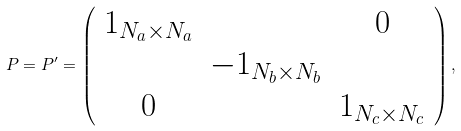<formula> <loc_0><loc_0><loc_500><loc_500>P = P ^ { \prime } = \left ( \begin{array} { c c c } { 1 } _ { N _ { a } \times N _ { a } } & & 0 \\ & { - 1 } _ { N _ { b } \times N _ { b } } & \\ 0 & & { 1 } _ { N _ { c } \times N _ { c } } \end{array} \right ) ,</formula> 